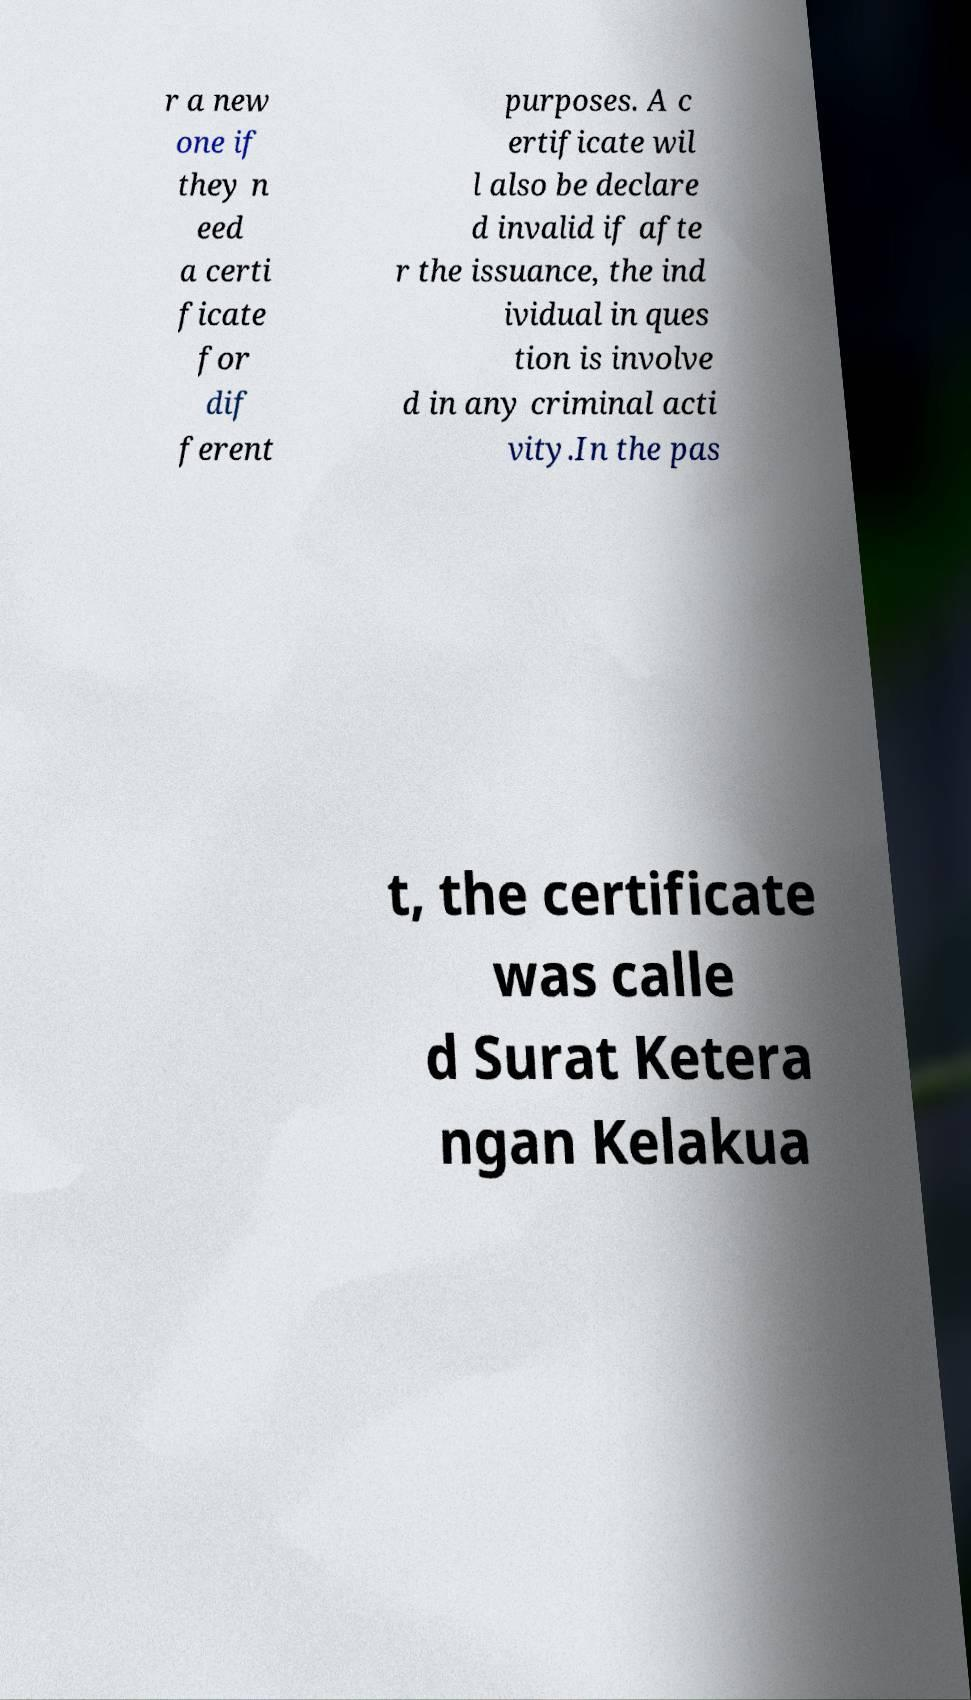What messages or text are displayed in this image? I need them in a readable, typed format. r a new one if they n eed a certi ficate for dif ferent purposes. A c ertificate wil l also be declare d invalid if afte r the issuance, the ind ividual in ques tion is involve d in any criminal acti vity.In the pas t, the certificate was calle d Surat Ketera ngan Kelakua 